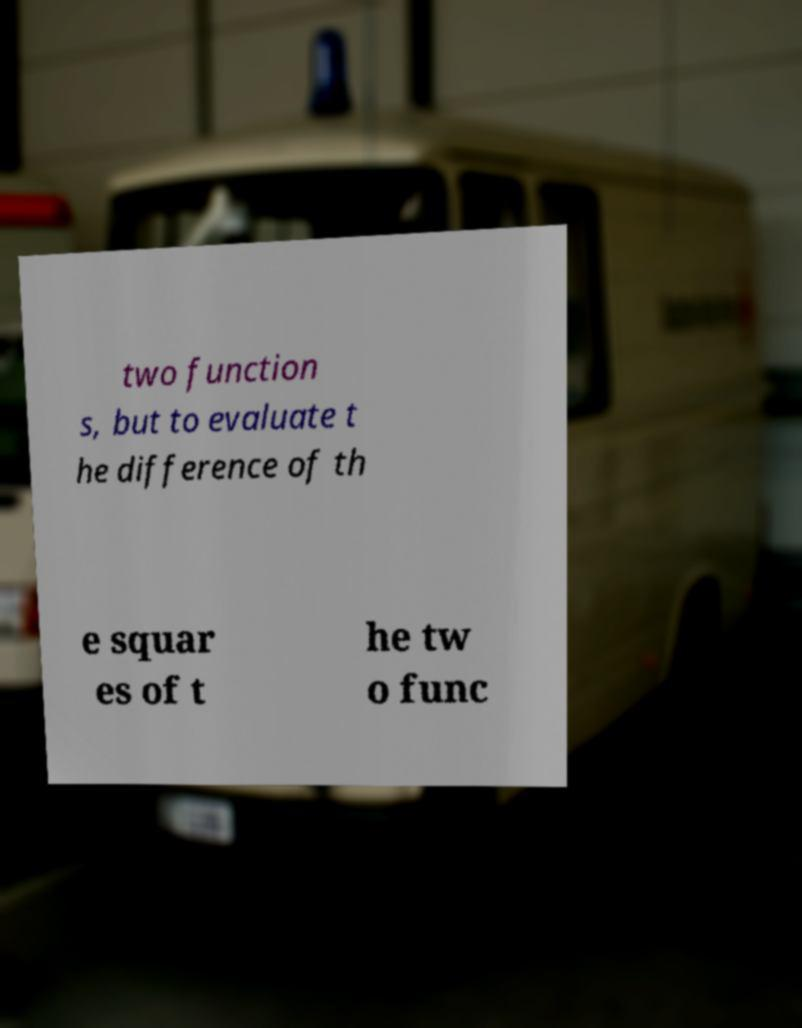Could you assist in decoding the text presented in this image and type it out clearly? two function s, but to evaluate t he difference of th e squar es of t he tw o func 